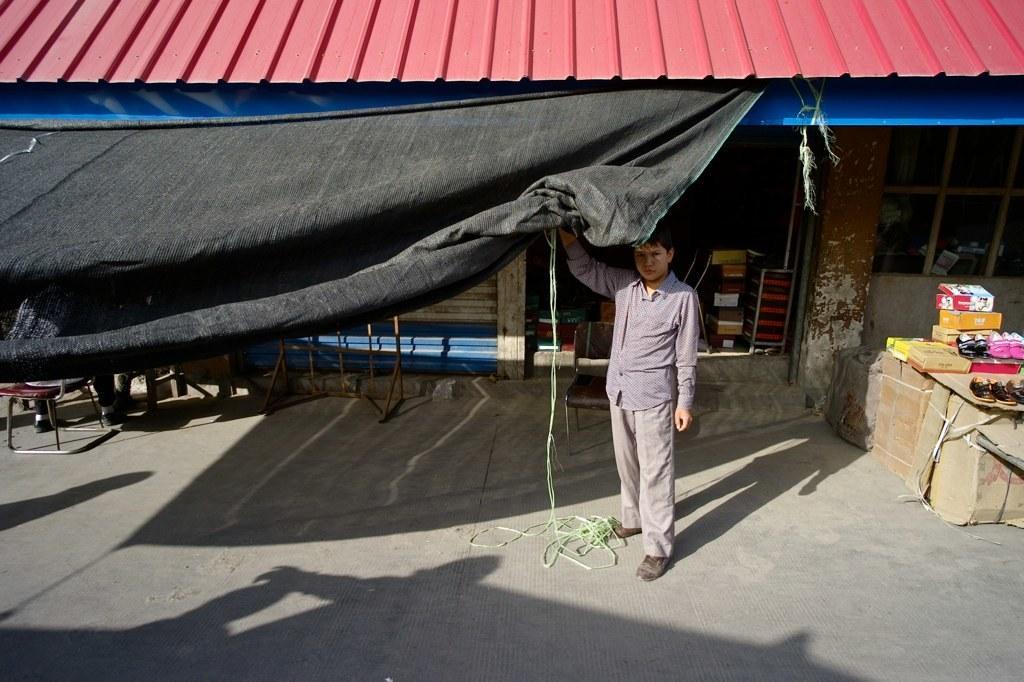Please provide a concise description of this image. In this image there is a man tent cloth, in the background there is a shop, on the right side there are boxes on above the boxes there are footwear. 